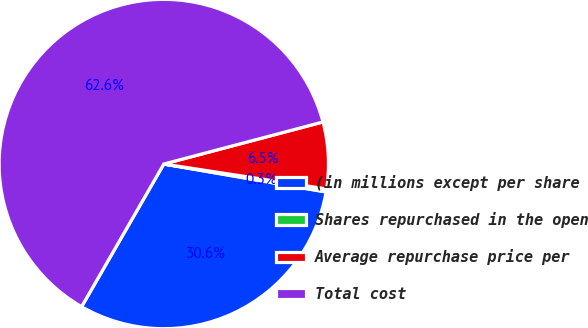<chart> <loc_0><loc_0><loc_500><loc_500><pie_chart><fcel>(in millions except per share<fcel>Shares repurchased in the open<fcel>Average repurchase price per<fcel>Total cost<nl><fcel>30.6%<fcel>0.3%<fcel>6.53%<fcel>62.57%<nl></chart> 